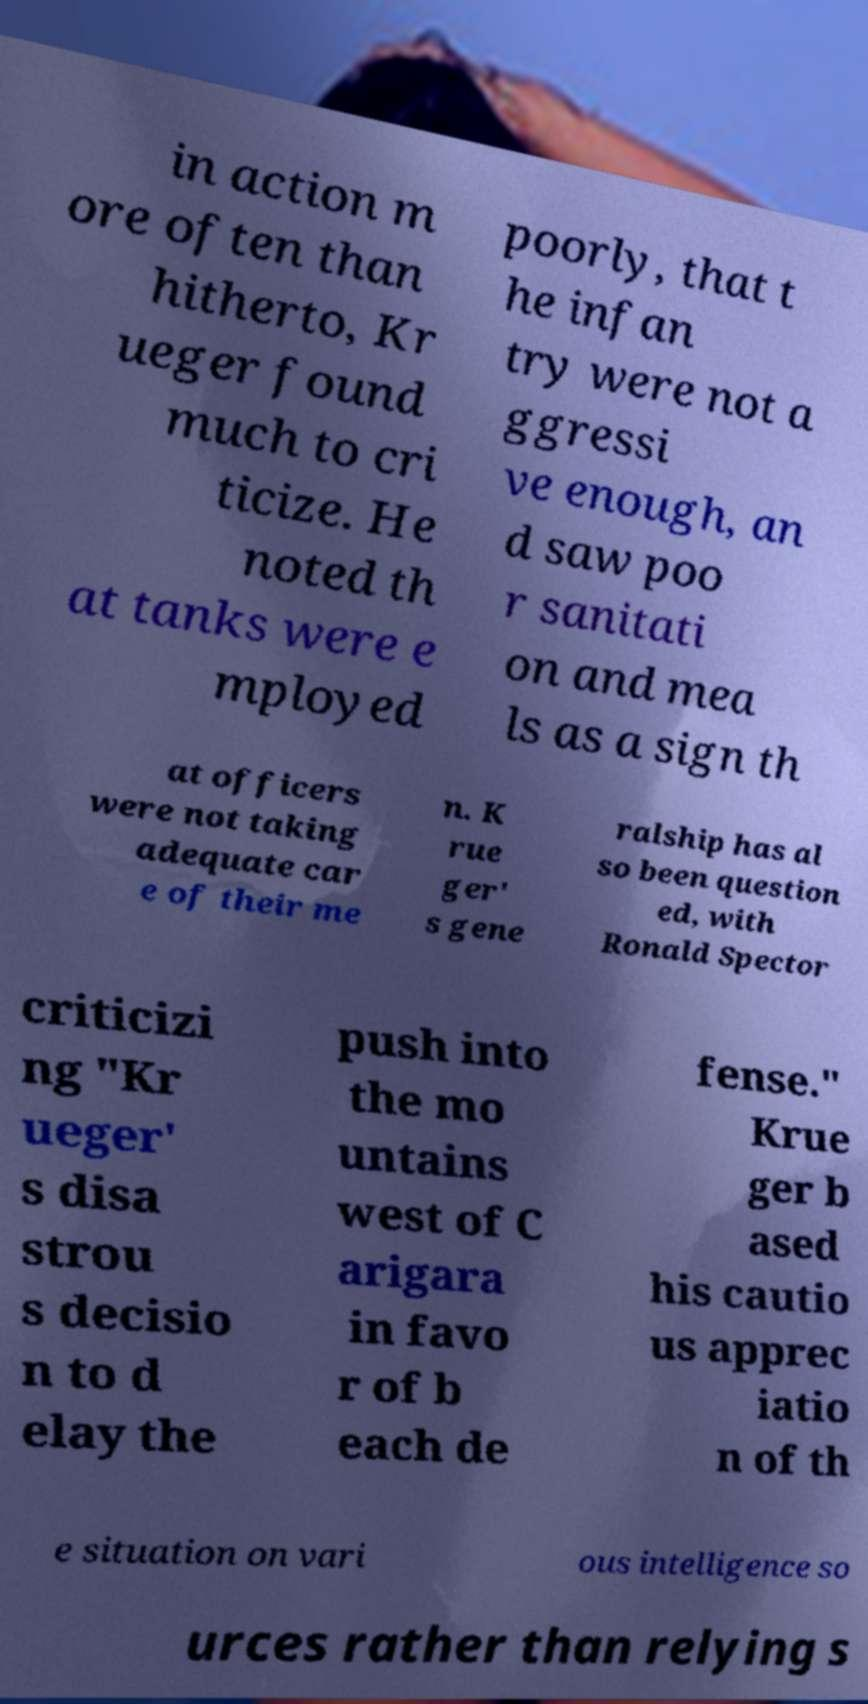Can you accurately transcribe the text from the provided image for me? in action m ore often than hitherto, Kr ueger found much to cri ticize. He noted th at tanks were e mployed poorly, that t he infan try were not a ggressi ve enough, an d saw poo r sanitati on and mea ls as a sign th at officers were not taking adequate car e of their me n. K rue ger' s gene ralship has al so been question ed, with Ronald Spector criticizi ng "Kr ueger' s disa strou s decisio n to d elay the push into the mo untains west of C arigara in favo r of b each de fense." Krue ger b ased his cautio us apprec iatio n of th e situation on vari ous intelligence so urces rather than relying s 